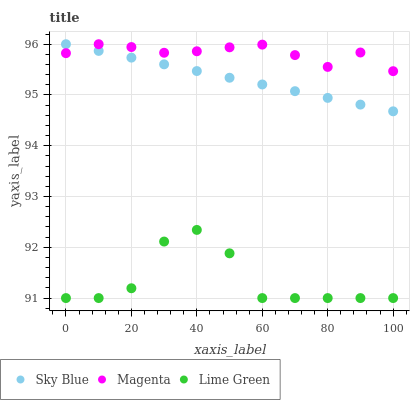Does Lime Green have the minimum area under the curve?
Answer yes or no. Yes. Does Magenta have the maximum area under the curve?
Answer yes or no. Yes. Does Magenta have the minimum area under the curve?
Answer yes or no. No. Does Lime Green have the maximum area under the curve?
Answer yes or no. No. Is Sky Blue the smoothest?
Answer yes or no. Yes. Is Lime Green the roughest?
Answer yes or no. Yes. Is Magenta the smoothest?
Answer yes or no. No. Is Magenta the roughest?
Answer yes or no. No. Does Lime Green have the lowest value?
Answer yes or no. Yes. Does Magenta have the lowest value?
Answer yes or no. No. Does Magenta have the highest value?
Answer yes or no. Yes. Does Lime Green have the highest value?
Answer yes or no. No. Is Lime Green less than Magenta?
Answer yes or no. Yes. Is Sky Blue greater than Lime Green?
Answer yes or no. Yes. Does Magenta intersect Sky Blue?
Answer yes or no. Yes. Is Magenta less than Sky Blue?
Answer yes or no. No. Is Magenta greater than Sky Blue?
Answer yes or no. No. Does Lime Green intersect Magenta?
Answer yes or no. No. 